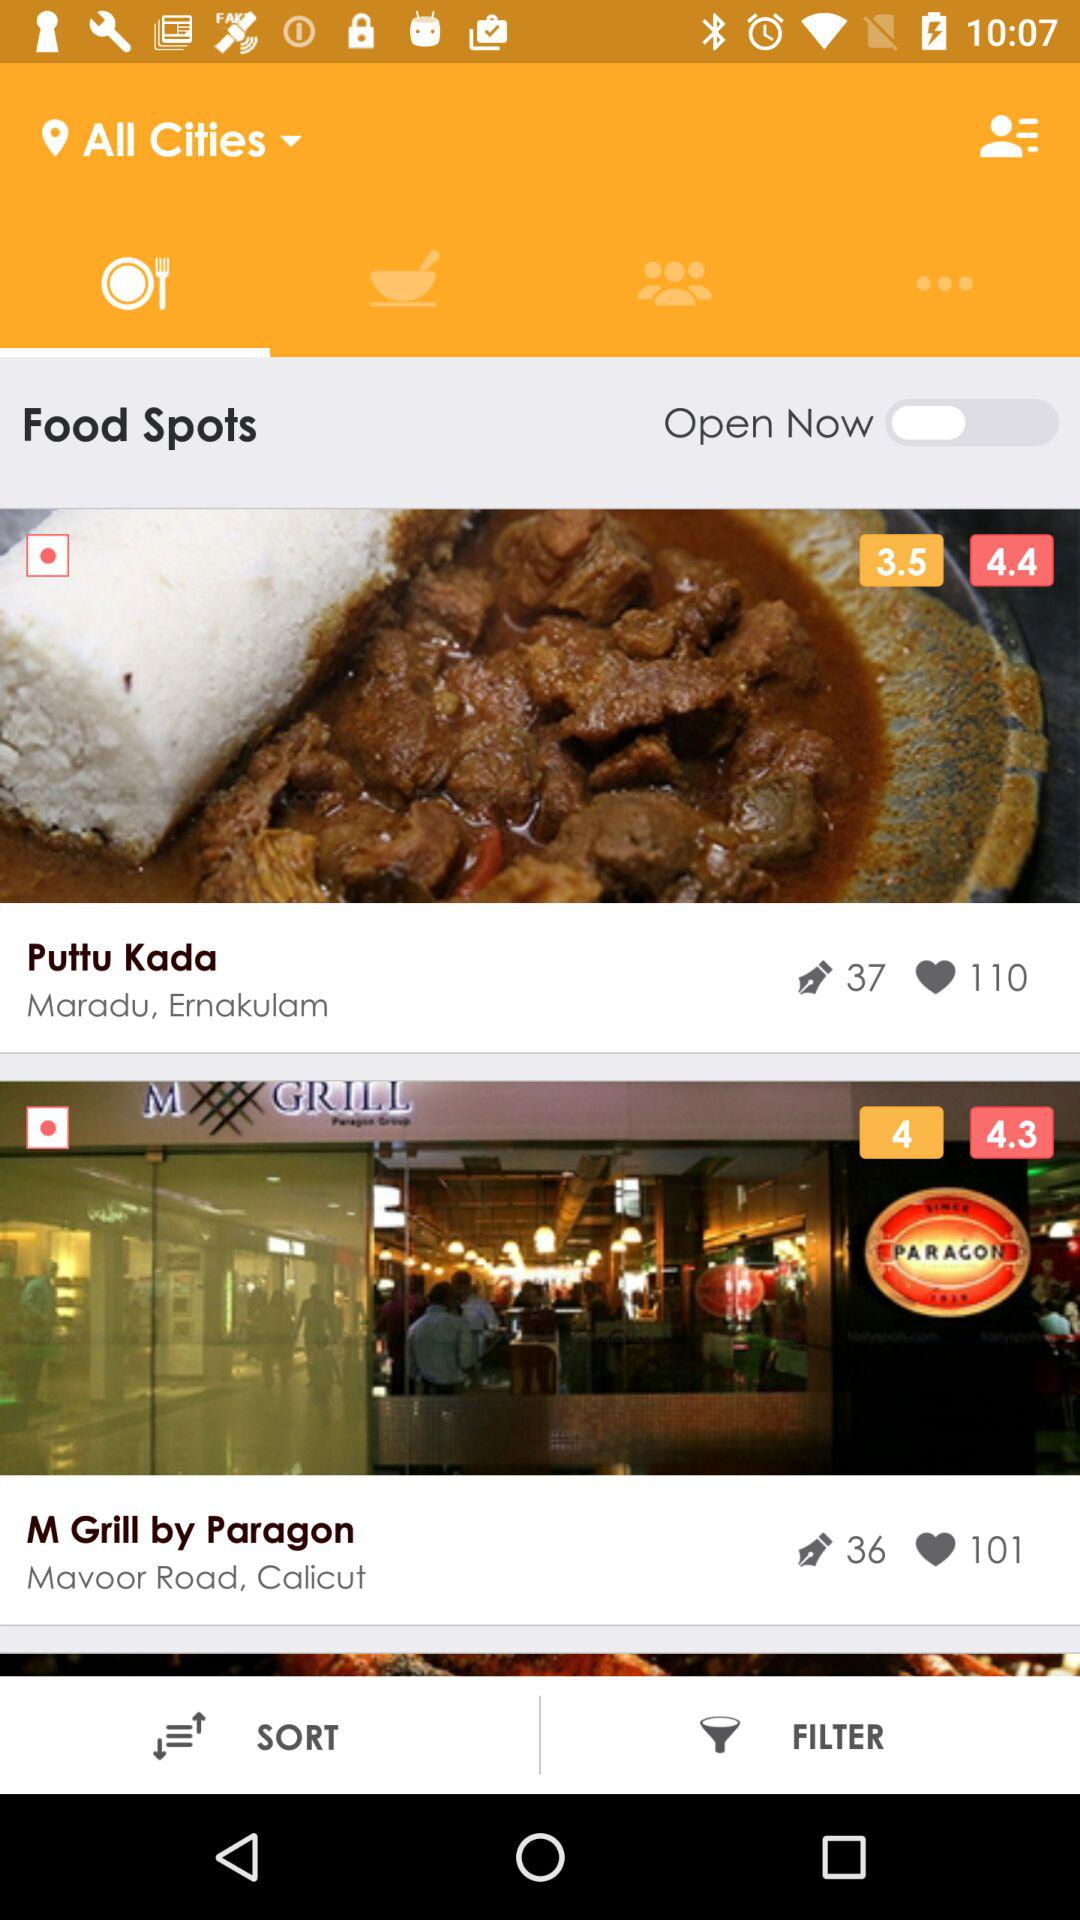How many restaurants have a rating of 4.3 or higher?
Answer the question using a single word or phrase. 2 